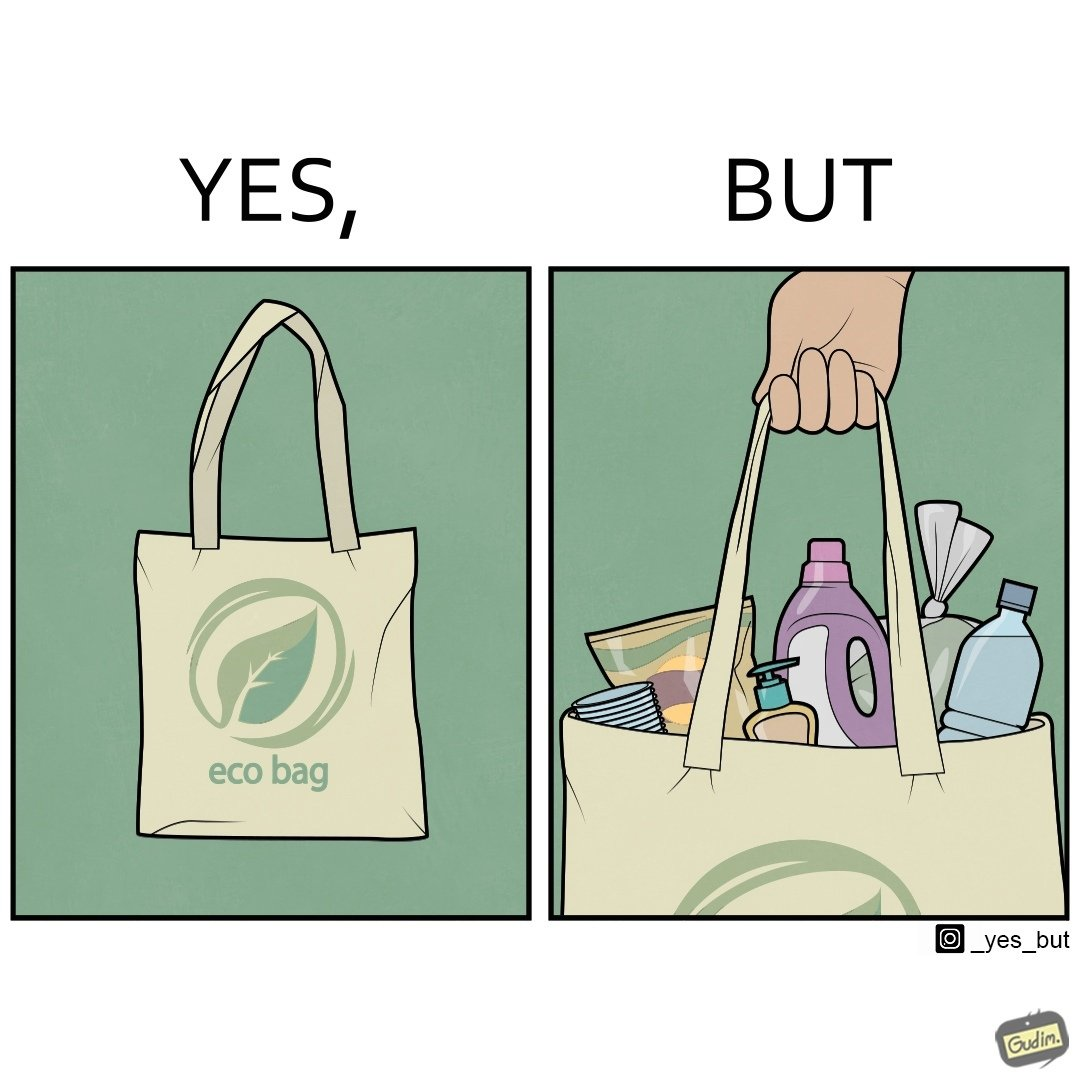Describe the content of this image. The image is ironic, because people nowadays use eco-bag thinking them as safe for the environment but in turn use products which are harmful for the environment or are packaged in some non-biodegradable material 